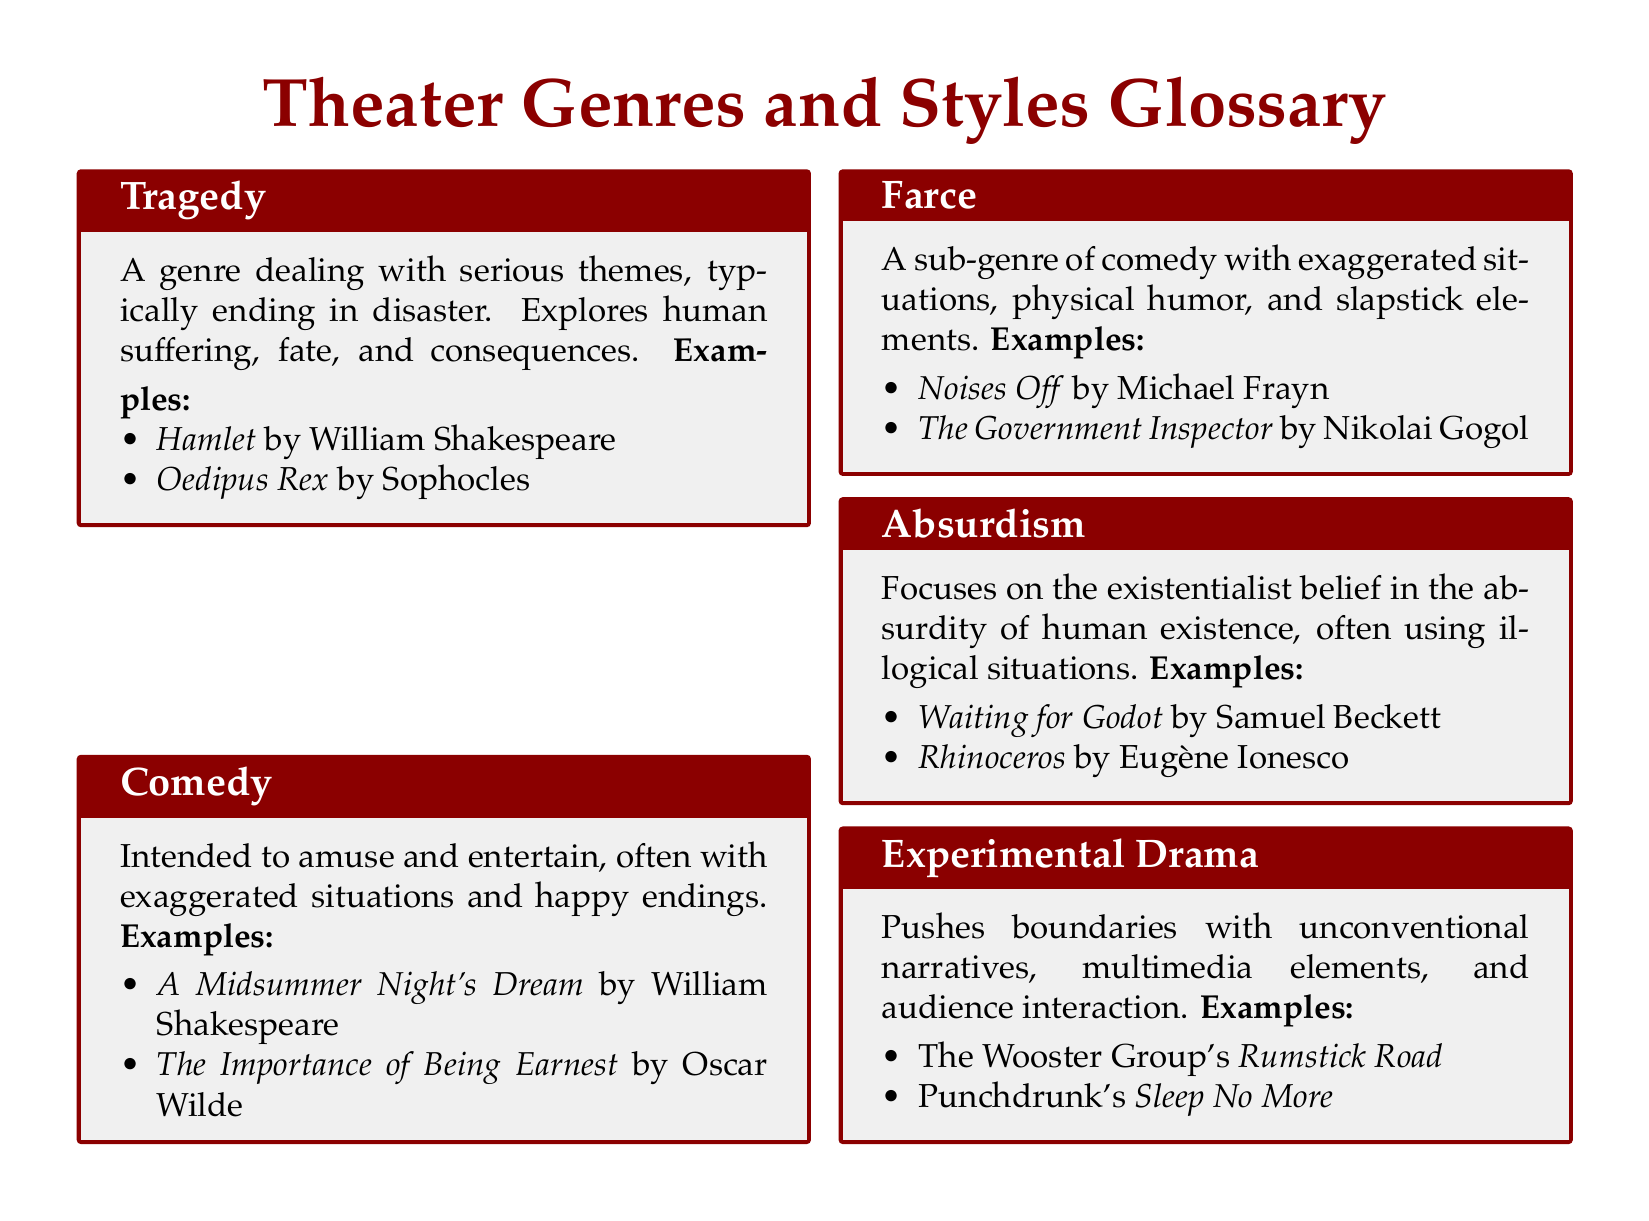What is the primary theme of Tragedy? Tragedy deals with serious themes, exploring human suffering, fate, and consequences.
Answer: Serious themes Which playwright wrote "The Importance of Being Earnest"? "The Importance of Being Earnest" is a notable play listed under Comedy, written by Oscar Wilde.
Answer: Oscar Wilde Name a notable play classified as Absurdism. Absurdism encompasses plays that highlight the absurdity of human existence; one notable play is "Waiting for Godot."
Answer: Waiting for Godot What is a defining characteristic of Farce? Farce is characterized by exaggerated situations, physical humor, and slapstick elements.
Answer: Exaggerated situations List an example of Experimental Drama. Experimental Drama often includes unconventional narratives; an example from the document is "Sleep No More."
Answer: Sleep No More What genre often ends in disaster? The genre that typically ends in disaster is Tragedy.
Answer: Tragedy What type of humor is emphasized in Farce? Farce emphasizes physical humor and slapstick elements.
Answer: Slapstick Name one play by William Shakespeare that falls under Comedy. Among the notable Comedies by Shakespeare, "A Midsummer Night's Dream" is specifically mentioned.
Answer: A Midsummer Night's Dream 